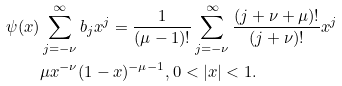Convert formula to latex. <formula><loc_0><loc_0><loc_500><loc_500>\psi ( x ) & \sum _ { j = - \nu } ^ { \infty } b _ { j } x ^ { j } = \frac { 1 } { ( \mu - 1 ) ! } \sum _ { j = - \nu } ^ { \infty } \frac { ( j + \nu + \mu ) ! } { ( j + \nu ) ! } x ^ { j } \\ & \mu x ^ { - \nu } ( 1 - x ) ^ { - \mu - 1 } , 0 < | x | < 1 .</formula> 